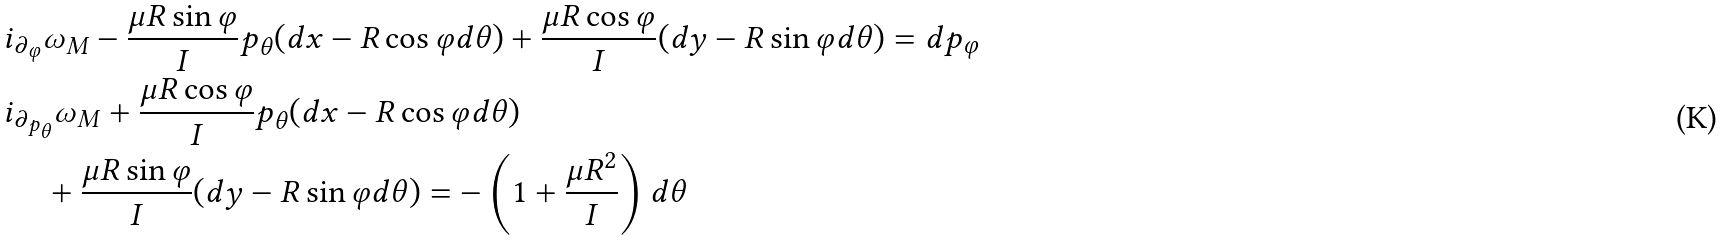<formula> <loc_0><loc_0><loc_500><loc_500>& { i } _ { \partial _ { \varphi } } \omega _ { M } - \frac { \mu R \sin \varphi } { I } p _ { \theta } ( d x - R \cos \varphi d \theta ) + \frac { \mu R \cos \varphi } { I } ( d y - R \sin \varphi d \theta ) = d p _ { \varphi } \\ & { i } _ { \partial _ { p _ { \theta } } } \omega _ { M } + \frac { \mu R \cos \varphi } { I } p _ { \theta } ( d x - R \cos \varphi d \theta ) \\ & \quad \, + \frac { \mu R \sin \varphi } { I } ( d y - R \sin \varphi d \theta ) = - \left ( 1 + \frac { \mu R ^ { 2 } } { I } \right ) d \theta</formula> 